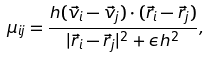Convert formula to latex. <formula><loc_0><loc_0><loc_500><loc_500>\mu _ { i j } = \frac { h ( \vec { v } _ { i } - \vec { v } _ { j } ) \cdot ( \vec { r } _ { i } - \vec { r } _ { j } ) } { | \vec { r } _ { i } - \vec { r } _ { j } | ^ { 2 } + \epsilon h ^ { 2 } } ,</formula> 